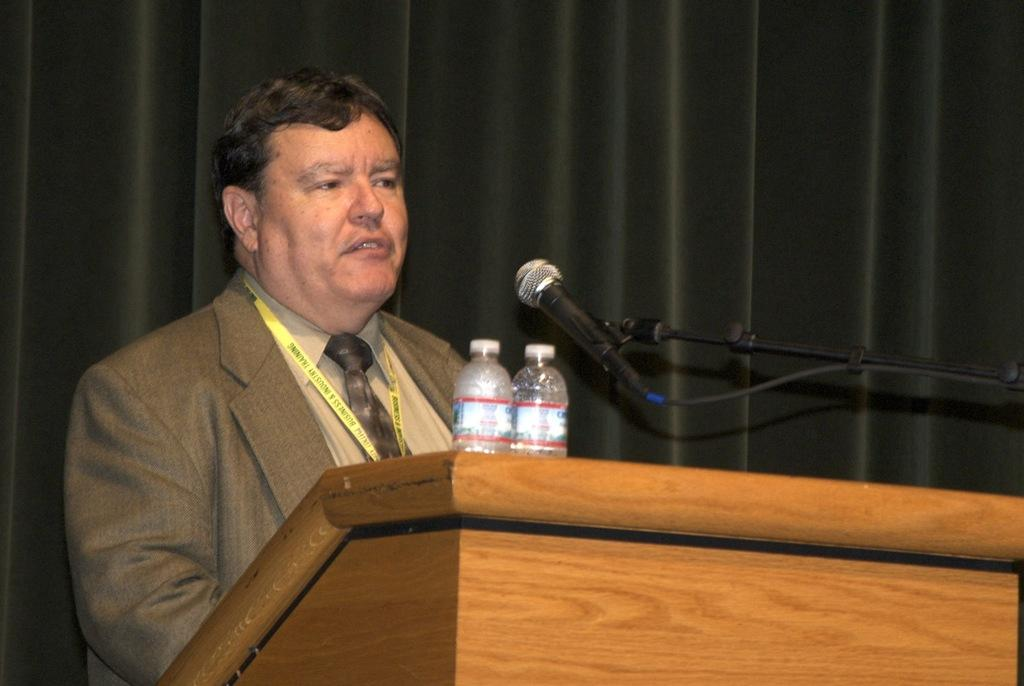What is the person in the image doing? The person is standing and talking with a mic. What can be seen near the person? There is a wooden podium near the person. Is there any object on a table in the image? Yes, there is a water bottle on a table. What is visible behind the person? There is a curtain behind the person. What type of garden can be seen in the image? There is no garden present in the image. What kind of meal is being prepared in the image? There is no meal preparation visible in the image. 